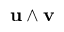Convert formula to latex. <formula><loc_0><loc_0><loc_500><loc_500>u \wedge v</formula> 